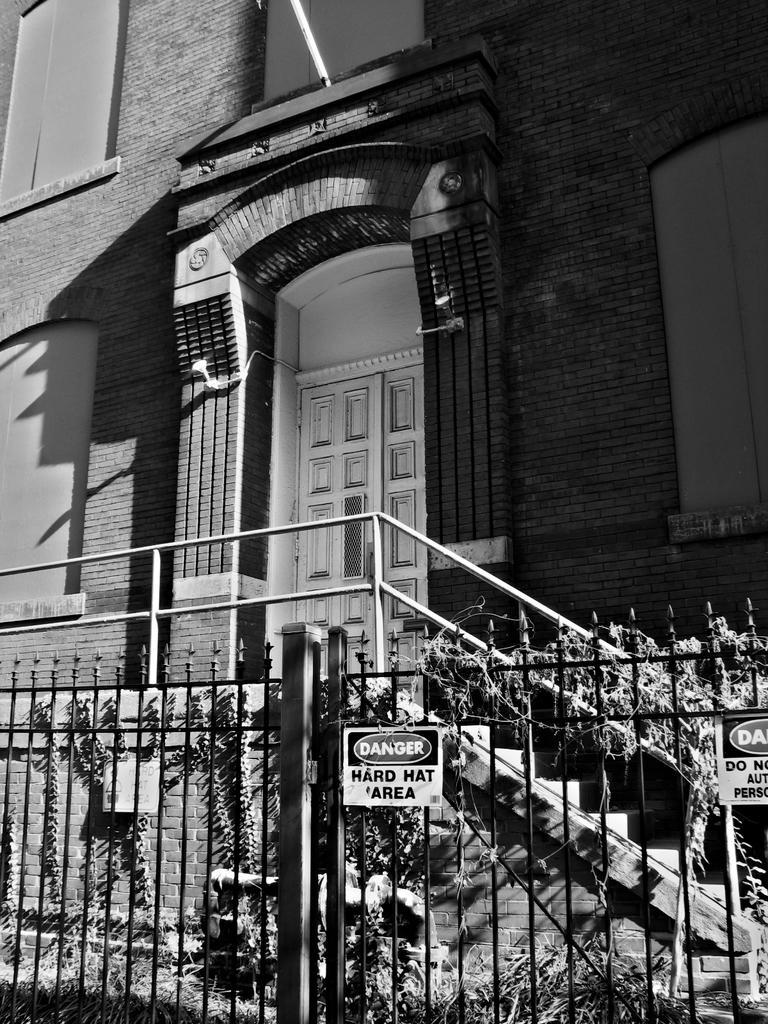Can you describe this image briefly? In front of the image there are boards with some text on it. There is a metal fence. There are creepers. At the bottom of the image there is grass on the surface. In the background of the image there are stairs. There is a railing. There is a closed door. There is a building. 